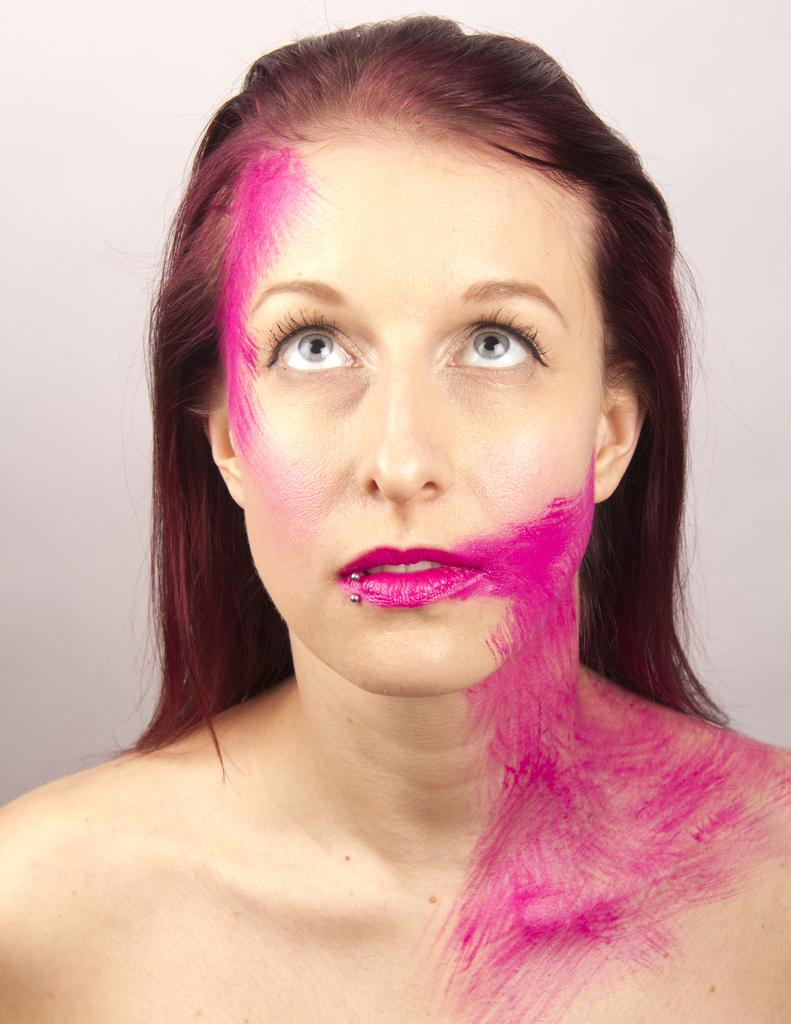Who is the main subject in the image? There is a woman in the image. What is the woman's attire in the image? The woman is not wearing clothes in the image. What direction is the woman looking in the image? The woman is looking upwards in the image. What colors are present near the woman's head and neck? There are pink color shades near her head and neck in the image. What scent can be detected from the woman in the image? There is no information about the scent of the woman in the image. --- Facts: 1. There is a car in the image. 2. The car is red. 3. The car has four wheels. 4. There are people sitting inside the car. 5. The car is parked on the street. Absurd Topics: dance, ocean, instrument Conversation: What is the main subject in the image? There is a car in the image. What color is the car? The car is red. How many wheels does the car have? The car has four wheels. Who is inside the car? There are people sitting inside the car. Where is the car located in the image? The car is parked on the street. Reasoning: Let's think step by step in order to produce the conversation. We start by identifying the main subject in the image, which is the car. Then, we describe the car's color and the number of wheels it has. Next, we mention the people inside the car and their location, which is parked on the street. Each question is designed to elicit a detail about the image that is known from the provided facts. Absurd Question/Answer: What type of dance is being performed by the car in the image? There is no indication of any dance being performed by the car in the image. 